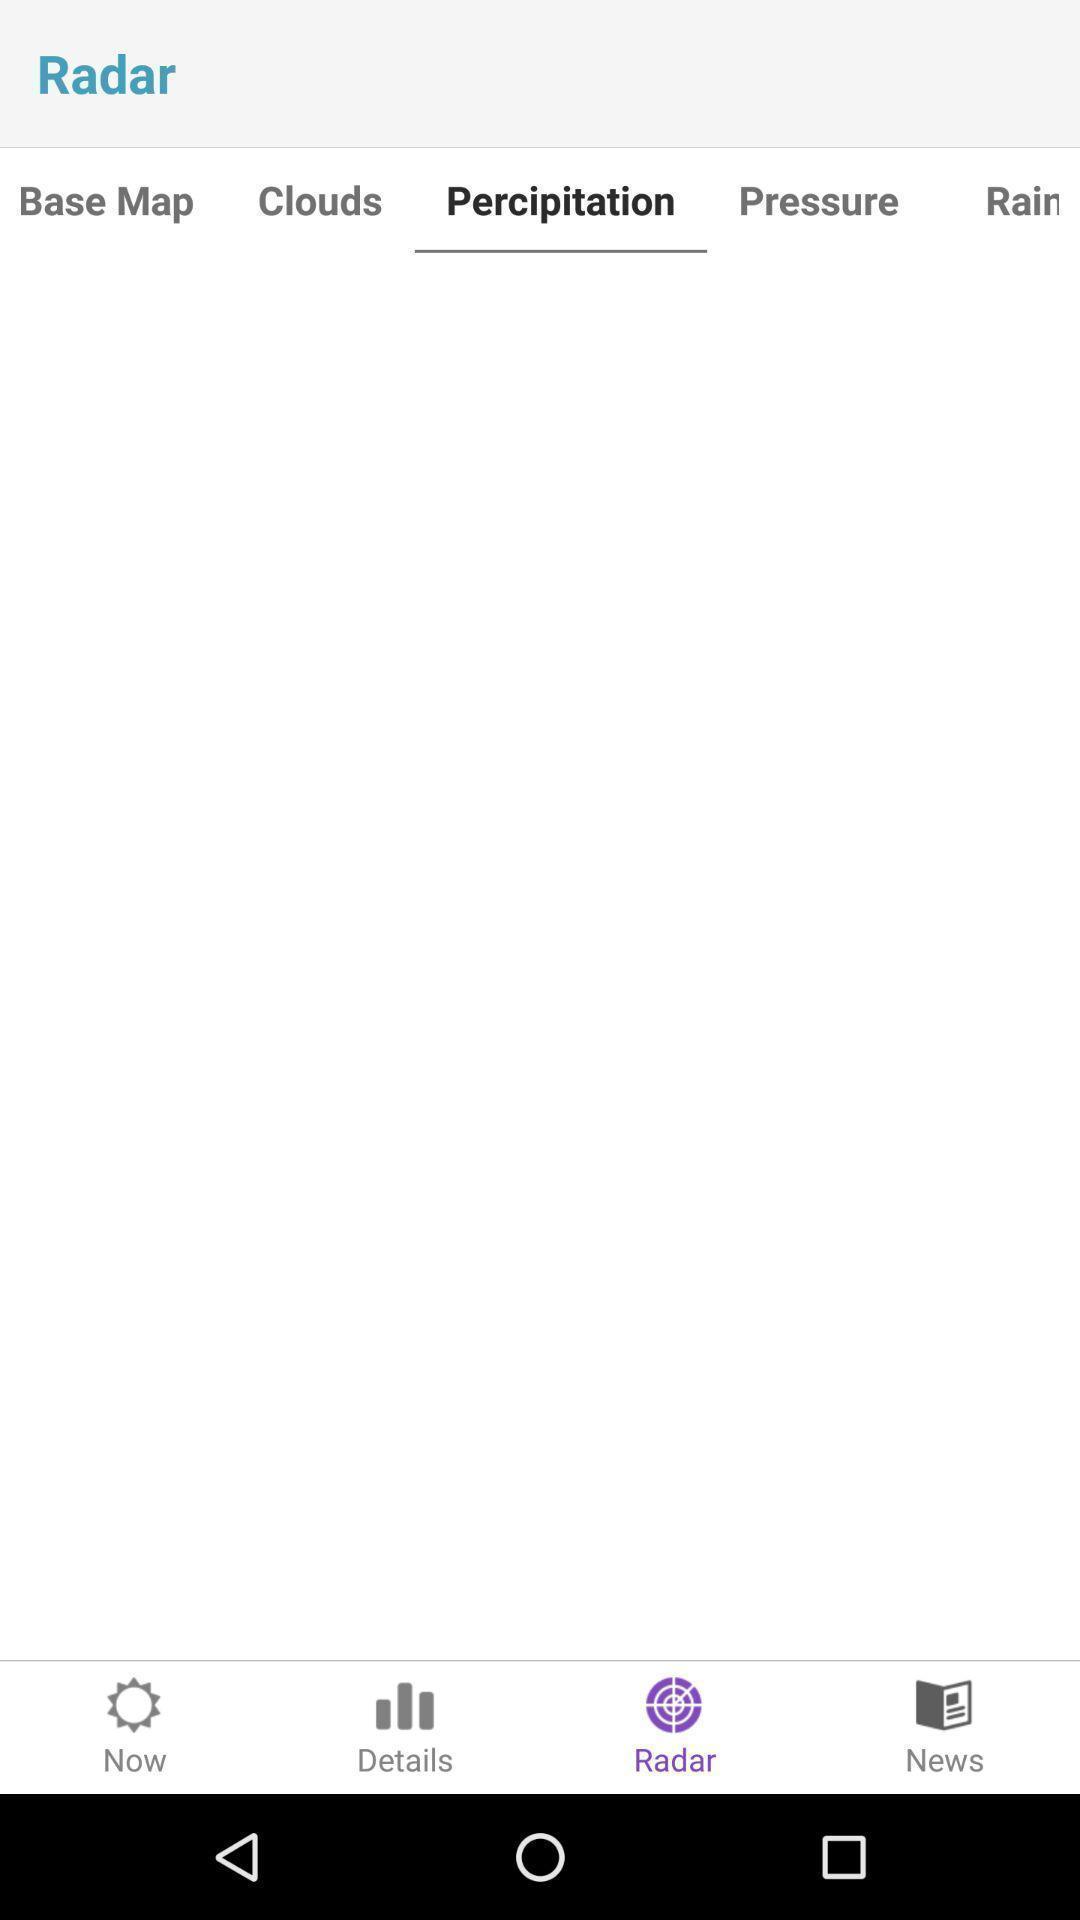Give me a summary of this screen capture. Precipitation tab in the application. 